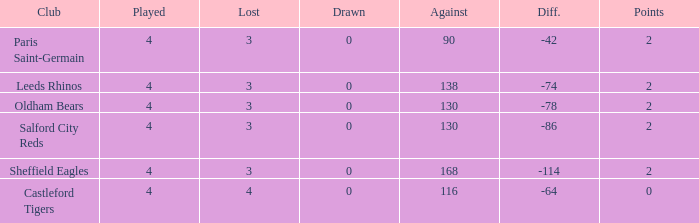What is the combined amount of losses for teams with less than 4 games played? None. 